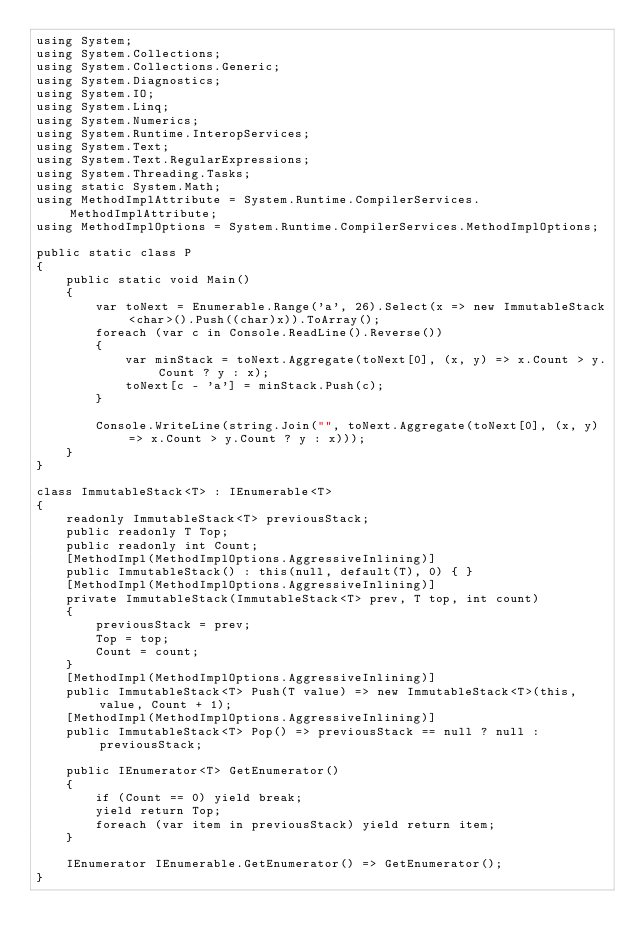<code> <loc_0><loc_0><loc_500><loc_500><_C#_>using System;
using System.Collections;
using System.Collections.Generic;
using System.Diagnostics;
using System.IO;
using System.Linq;
using System.Numerics;
using System.Runtime.InteropServices;
using System.Text;
using System.Text.RegularExpressions;
using System.Threading.Tasks;
using static System.Math;
using MethodImplAttribute = System.Runtime.CompilerServices.MethodImplAttribute;
using MethodImplOptions = System.Runtime.CompilerServices.MethodImplOptions;

public static class P
{
    public static void Main()
    {
        var toNext = Enumerable.Range('a', 26).Select(x => new ImmutableStack<char>().Push((char)x)).ToArray();
        foreach (var c in Console.ReadLine().Reverse())
        {
            var minStack = toNext.Aggregate(toNext[0], (x, y) => x.Count > y.Count ? y : x);
            toNext[c - 'a'] = minStack.Push(c);
        }

        Console.WriteLine(string.Join("", toNext.Aggregate(toNext[0], (x, y) => x.Count > y.Count ? y : x)));
    }
}

class ImmutableStack<T> : IEnumerable<T>
{
    readonly ImmutableStack<T> previousStack;
    public readonly T Top;
    public readonly int Count;
    [MethodImpl(MethodImplOptions.AggressiveInlining)]
    public ImmutableStack() : this(null, default(T), 0) { }
    [MethodImpl(MethodImplOptions.AggressiveInlining)]
    private ImmutableStack(ImmutableStack<T> prev, T top, int count)
    {
        previousStack = prev;
        Top = top;
        Count = count;
    }
    [MethodImpl(MethodImplOptions.AggressiveInlining)]
    public ImmutableStack<T> Push(T value) => new ImmutableStack<T>(this, value, Count + 1);
    [MethodImpl(MethodImplOptions.AggressiveInlining)]
    public ImmutableStack<T> Pop() => previousStack == null ? null : previousStack;

    public IEnumerator<T> GetEnumerator()
    {
        if (Count == 0) yield break;
        yield return Top;
        foreach (var item in previousStack) yield return item;
    }

    IEnumerator IEnumerable.GetEnumerator() => GetEnumerator();
}
</code> 